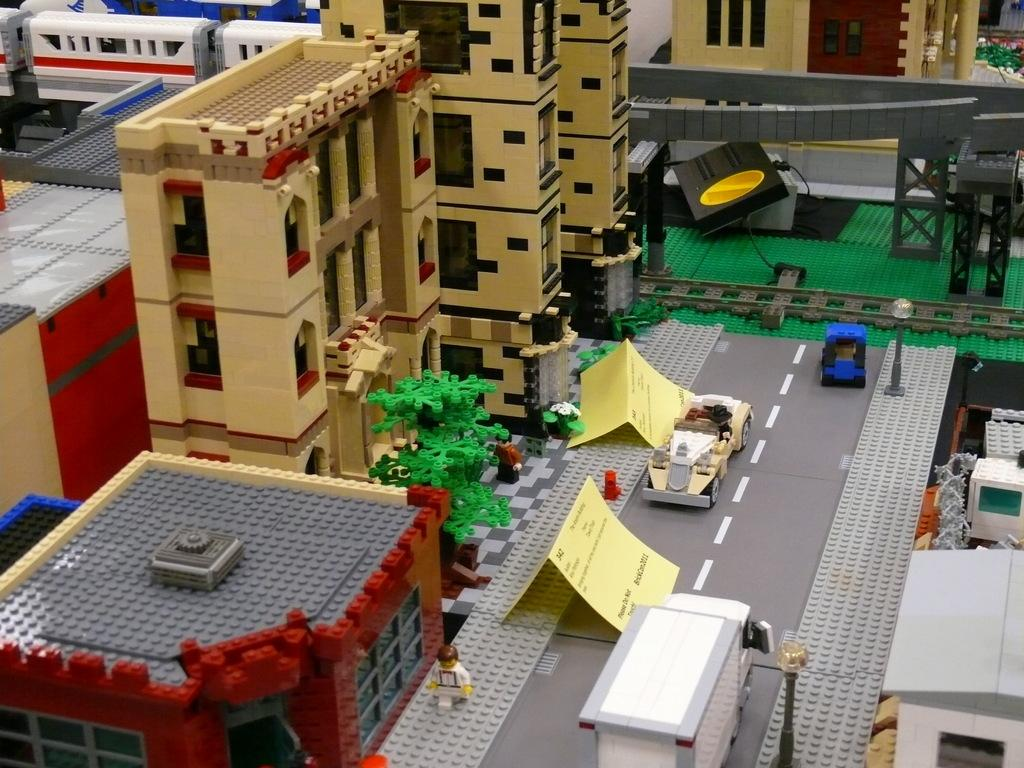What type of objects are present in the image? There are building blocks and toys in the image. Can you describe the toys in the image? The toys are not specified, but they are present in the image. Are there any toys visible in the background of the image? Yes, there are toys visible in the background of the image. What type of garden can be seen in the image? There is no garden present in the image; it features building blocks and toys. What scale is used to measure the toys in the image? There is no scale present in the image, and the toys are not being measured. 